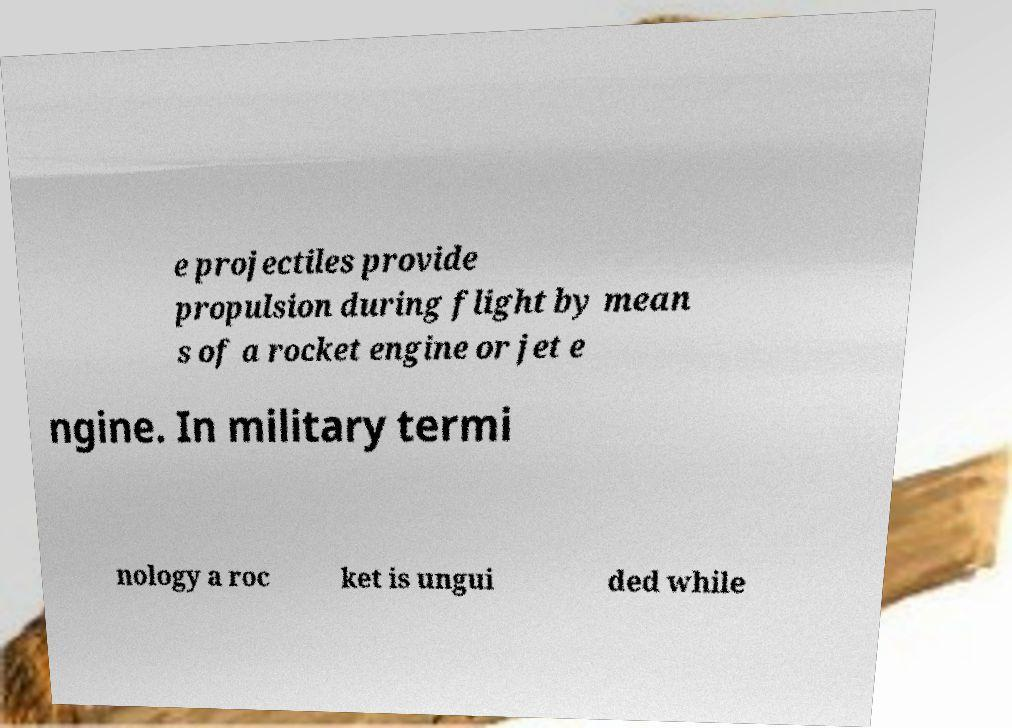For documentation purposes, I need the text within this image transcribed. Could you provide that? e projectiles provide propulsion during flight by mean s of a rocket engine or jet e ngine. In military termi nology a roc ket is ungui ded while 